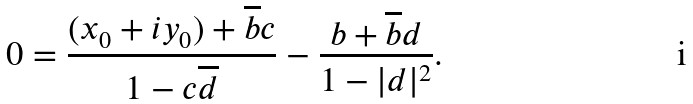Convert formula to latex. <formula><loc_0><loc_0><loc_500><loc_500>0 = \frac { ( x _ { 0 } + i y _ { 0 } ) + \overline { b } c } { 1 - c \overline { d } } - \frac { b + \overline { b } d } { 1 - | d | ^ { 2 } } .</formula> 